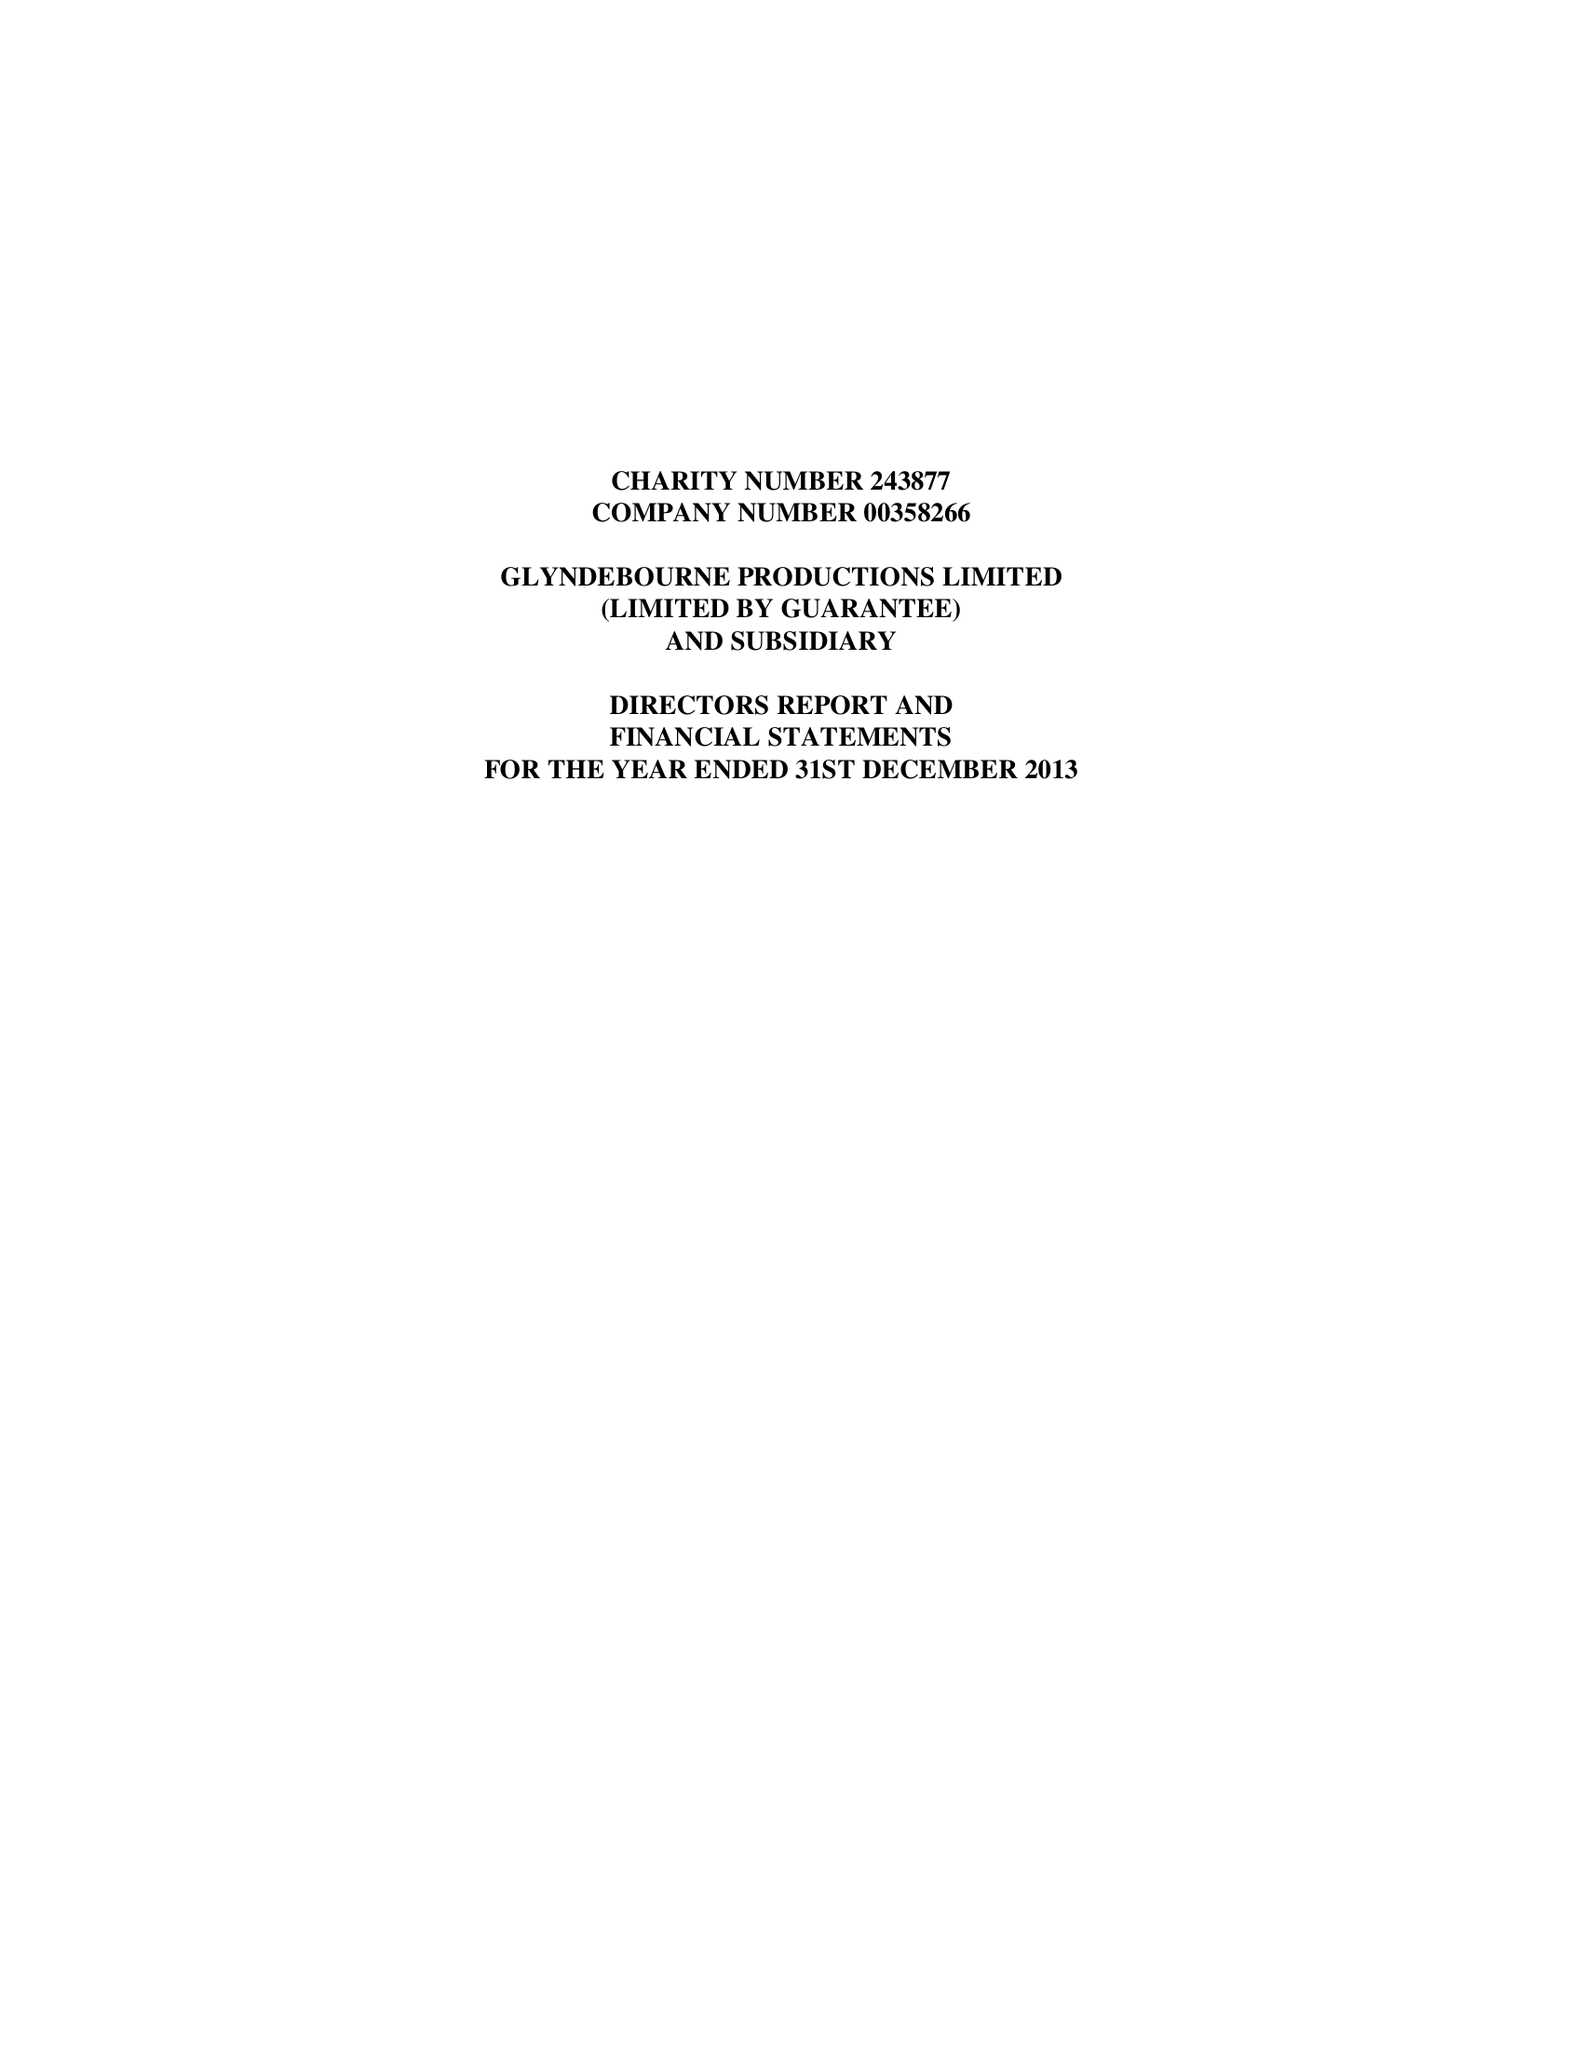What is the value for the income_annually_in_british_pounds?
Answer the question using a single word or phrase. 25126146.00 